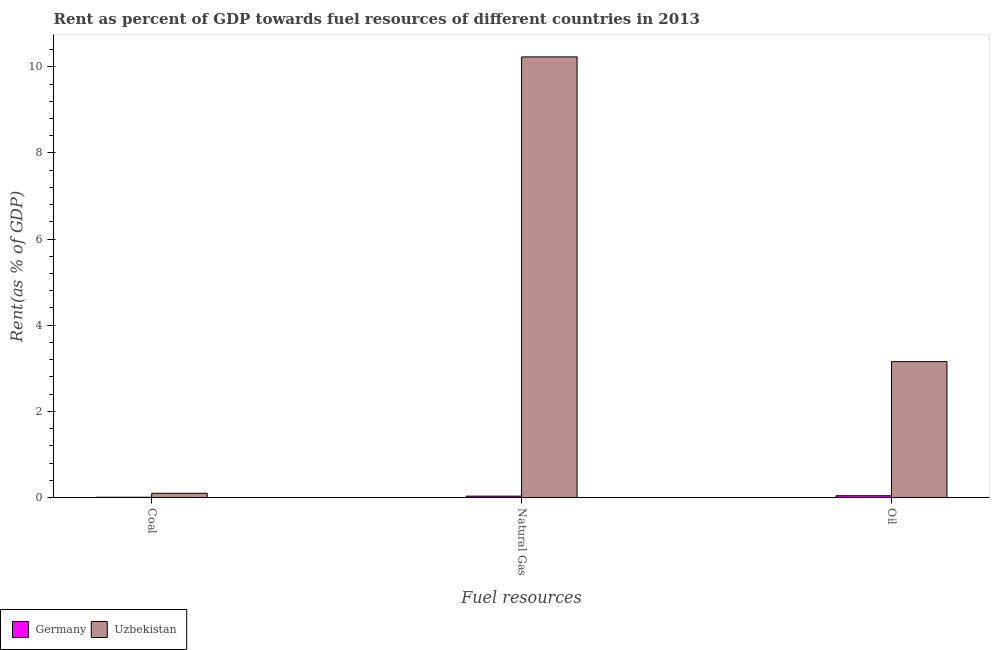How many different coloured bars are there?
Offer a terse response. 2. How many groups of bars are there?
Give a very brief answer. 3. Are the number of bars per tick equal to the number of legend labels?
Ensure brevity in your answer.  Yes. How many bars are there on the 2nd tick from the left?
Your answer should be very brief. 2. How many bars are there on the 2nd tick from the right?
Your answer should be compact. 2. What is the label of the 2nd group of bars from the left?
Provide a short and direct response. Natural Gas. What is the rent towards natural gas in Germany?
Offer a very short reply. 0.03. Across all countries, what is the maximum rent towards coal?
Give a very brief answer. 0.1. Across all countries, what is the minimum rent towards natural gas?
Offer a very short reply. 0.03. In which country was the rent towards oil maximum?
Ensure brevity in your answer.  Uzbekistan. What is the total rent towards natural gas in the graph?
Your answer should be compact. 10.26. What is the difference between the rent towards oil in Uzbekistan and that in Germany?
Offer a terse response. 3.11. What is the difference between the rent towards natural gas in Germany and the rent towards coal in Uzbekistan?
Provide a short and direct response. -0.07. What is the average rent towards natural gas per country?
Keep it short and to the point. 5.13. What is the difference between the rent towards coal and rent towards natural gas in Germany?
Give a very brief answer. -0.03. In how many countries, is the rent towards natural gas greater than 9.6 %?
Keep it short and to the point. 1. What is the ratio of the rent towards coal in Uzbekistan to that in Germany?
Provide a short and direct response. 16.55. What is the difference between the highest and the second highest rent towards oil?
Keep it short and to the point. 3.11. What is the difference between the highest and the lowest rent towards natural gas?
Your response must be concise. 10.2. In how many countries, is the rent towards coal greater than the average rent towards coal taken over all countries?
Ensure brevity in your answer.  1. What does the 1st bar from the left in Natural Gas represents?
Make the answer very short. Germany. How many countries are there in the graph?
Give a very brief answer. 2. What is the difference between two consecutive major ticks on the Y-axis?
Offer a terse response. 2. Where does the legend appear in the graph?
Your response must be concise. Bottom left. How many legend labels are there?
Give a very brief answer. 2. What is the title of the graph?
Offer a terse response. Rent as percent of GDP towards fuel resources of different countries in 2013. Does "Gabon" appear as one of the legend labels in the graph?
Provide a short and direct response. No. What is the label or title of the X-axis?
Offer a very short reply. Fuel resources. What is the label or title of the Y-axis?
Offer a very short reply. Rent(as % of GDP). What is the Rent(as % of GDP) in Germany in Coal?
Offer a terse response. 0.01. What is the Rent(as % of GDP) of Uzbekistan in Coal?
Provide a succinct answer. 0.1. What is the Rent(as % of GDP) of Germany in Natural Gas?
Ensure brevity in your answer.  0.03. What is the Rent(as % of GDP) in Uzbekistan in Natural Gas?
Your answer should be compact. 10.23. What is the Rent(as % of GDP) of Germany in Oil?
Provide a short and direct response. 0.04. What is the Rent(as % of GDP) in Uzbekistan in Oil?
Keep it short and to the point. 3.15. Across all Fuel resources, what is the maximum Rent(as % of GDP) of Germany?
Offer a very short reply. 0.04. Across all Fuel resources, what is the maximum Rent(as % of GDP) of Uzbekistan?
Your answer should be very brief. 10.23. Across all Fuel resources, what is the minimum Rent(as % of GDP) of Germany?
Your answer should be compact. 0.01. Across all Fuel resources, what is the minimum Rent(as % of GDP) in Uzbekistan?
Your answer should be compact. 0.1. What is the total Rent(as % of GDP) of Germany in the graph?
Your response must be concise. 0.08. What is the total Rent(as % of GDP) of Uzbekistan in the graph?
Your answer should be compact. 13.48. What is the difference between the Rent(as % of GDP) in Germany in Coal and that in Natural Gas?
Make the answer very short. -0.03. What is the difference between the Rent(as % of GDP) in Uzbekistan in Coal and that in Natural Gas?
Make the answer very short. -10.13. What is the difference between the Rent(as % of GDP) in Germany in Coal and that in Oil?
Your answer should be very brief. -0.03. What is the difference between the Rent(as % of GDP) of Uzbekistan in Coal and that in Oil?
Offer a very short reply. -3.06. What is the difference between the Rent(as % of GDP) of Germany in Natural Gas and that in Oil?
Your answer should be very brief. -0.01. What is the difference between the Rent(as % of GDP) in Uzbekistan in Natural Gas and that in Oil?
Your response must be concise. 7.08. What is the difference between the Rent(as % of GDP) in Germany in Coal and the Rent(as % of GDP) in Uzbekistan in Natural Gas?
Your answer should be compact. -10.22. What is the difference between the Rent(as % of GDP) of Germany in Coal and the Rent(as % of GDP) of Uzbekistan in Oil?
Make the answer very short. -3.15. What is the difference between the Rent(as % of GDP) of Germany in Natural Gas and the Rent(as % of GDP) of Uzbekistan in Oil?
Give a very brief answer. -3.12. What is the average Rent(as % of GDP) of Germany per Fuel resources?
Your answer should be very brief. 0.03. What is the average Rent(as % of GDP) in Uzbekistan per Fuel resources?
Provide a short and direct response. 4.49. What is the difference between the Rent(as % of GDP) in Germany and Rent(as % of GDP) in Uzbekistan in Coal?
Give a very brief answer. -0.09. What is the difference between the Rent(as % of GDP) of Germany and Rent(as % of GDP) of Uzbekistan in Natural Gas?
Make the answer very short. -10.2. What is the difference between the Rent(as % of GDP) in Germany and Rent(as % of GDP) in Uzbekistan in Oil?
Your answer should be compact. -3.11. What is the ratio of the Rent(as % of GDP) in Germany in Coal to that in Natural Gas?
Your response must be concise. 0.19. What is the ratio of the Rent(as % of GDP) in Uzbekistan in Coal to that in Natural Gas?
Your answer should be compact. 0.01. What is the ratio of the Rent(as % of GDP) in Germany in Coal to that in Oil?
Give a very brief answer. 0.15. What is the ratio of the Rent(as % of GDP) in Uzbekistan in Coal to that in Oil?
Your answer should be compact. 0.03. What is the ratio of the Rent(as % of GDP) in Germany in Natural Gas to that in Oil?
Offer a very short reply. 0.77. What is the ratio of the Rent(as % of GDP) of Uzbekistan in Natural Gas to that in Oil?
Make the answer very short. 3.24. What is the difference between the highest and the second highest Rent(as % of GDP) in Germany?
Give a very brief answer. 0.01. What is the difference between the highest and the second highest Rent(as % of GDP) in Uzbekistan?
Ensure brevity in your answer.  7.08. What is the difference between the highest and the lowest Rent(as % of GDP) in Germany?
Ensure brevity in your answer.  0.03. What is the difference between the highest and the lowest Rent(as % of GDP) in Uzbekistan?
Make the answer very short. 10.13. 